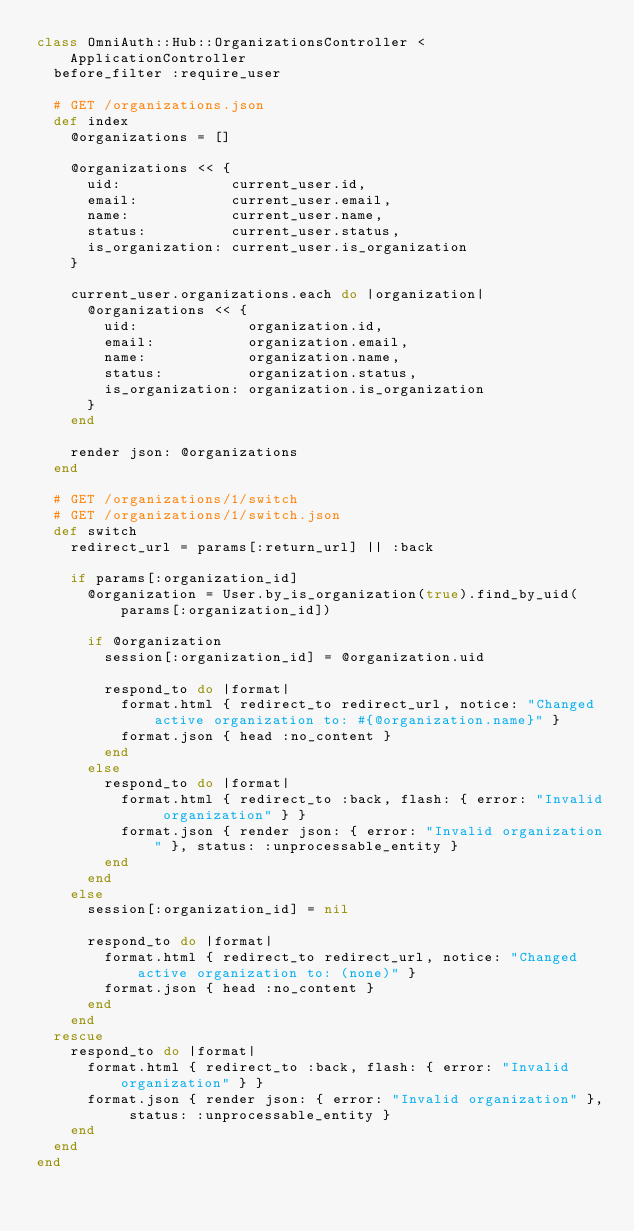<code> <loc_0><loc_0><loc_500><loc_500><_Ruby_>class OmniAuth::Hub::OrganizationsController < ApplicationController
  before_filter :require_user

  # GET /organizations.json
  def index
    @organizations = []

    @organizations << {
      uid:             current_user.id,
      email:           current_user.email,
      name:            current_user.name,
      status:          current_user.status,
      is_organization: current_user.is_organization
    }

    current_user.organizations.each do |organization|
      @organizations << {
        uid:             organization.id,
        email:           organization.email,
        name:            organization.name,
        status:          organization.status,
        is_organization: organization.is_organization
      }
    end

    render json: @organizations
  end

  # GET /organizations/1/switch
  # GET /organizations/1/switch.json
  def switch
    redirect_url = params[:return_url] || :back

    if params[:organization_id]
      @organization = User.by_is_organization(true).find_by_uid(params[:organization_id])

      if @organization
        session[:organization_id] = @organization.uid

        respond_to do |format|
          format.html { redirect_to redirect_url, notice: "Changed active organization to: #{@organization.name}" }
          format.json { head :no_content }
        end
      else
        respond_to do |format|
          format.html { redirect_to :back, flash: { error: "Invalid organization" } }
          format.json { render json: { error: "Invalid organization" }, status: :unprocessable_entity }
        end
      end
    else
      session[:organization_id] = nil

      respond_to do |format|
        format.html { redirect_to redirect_url, notice: "Changed active organization to: (none)" }
        format.json { head :no_content }
      end
    end
  rescue
    respond_to do |format|
      format.html { redirect_to :back, flash: { error: "Invalid organization" } }
      format.json { render json: { error: "Invalid organization" }, status: :unprocessable_entity }
    end
  end
end
</code> 